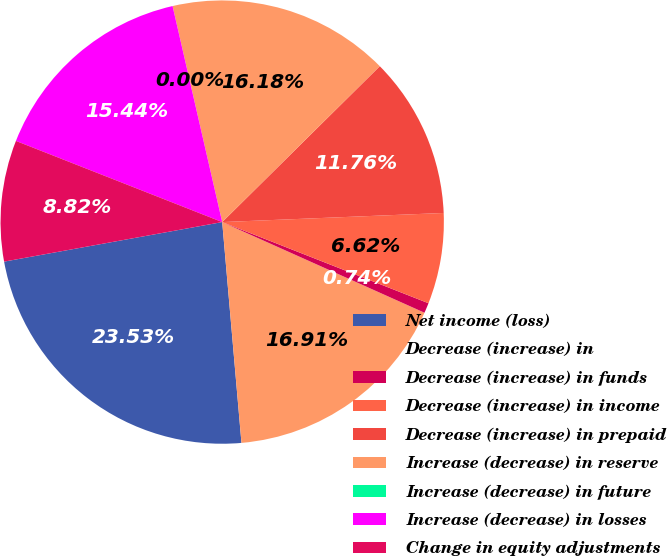Convert chart. <chart><loc_0><loc_0><loc_500><loc_500><pie_chart><fcel>Net income (loss)<fcel>Decrease (increase) in<fcel>Decrease (increase) in funds<fcel>Decrease (increase) in income<fcel>Decrease (increase) in prepaid<fcel>Increase (decrease) in reserve<fcel>Increase (decrease) in future<fcel>Increase (decrease) in losses<fcel>Change in equity adjustments<nl><fcel>23.53%<fcel>16.91%<fcel>0.74%<fcel>6.62%<fcel>11.76%<fcel>16.18%<fcel>0.0%<fcel>15.44%<fcel>8.82%<nl></chart> 